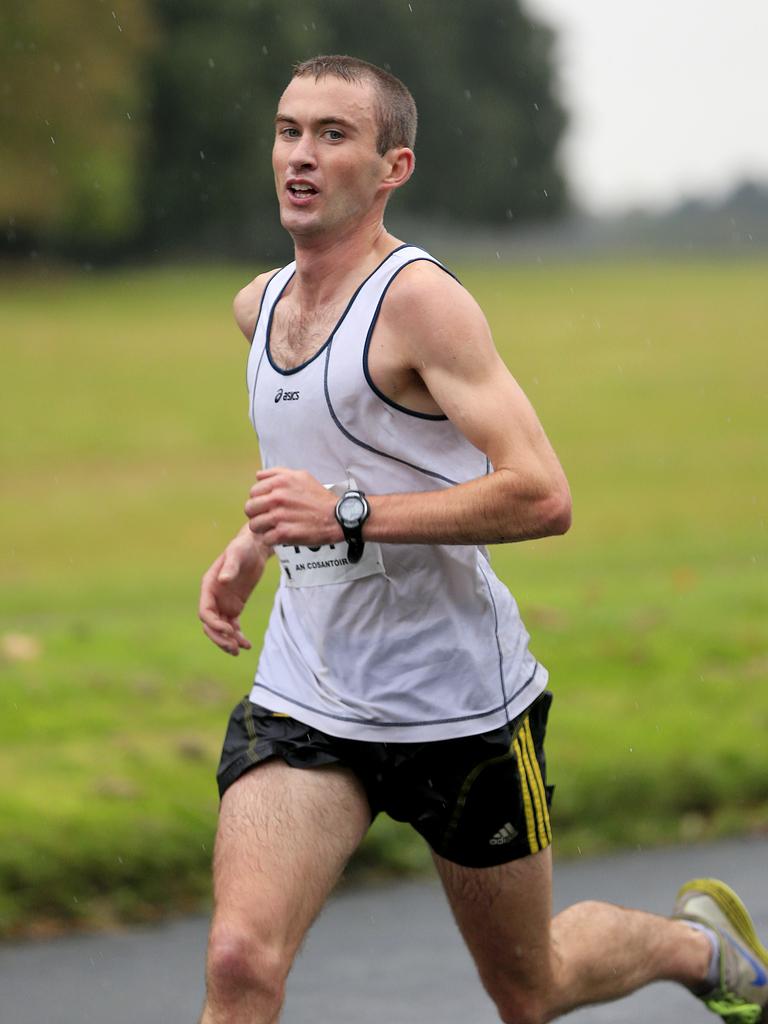What athletic brand is his shirt from?
Your answer should be compact. Asics. Are his shorts adidas?
Provide a short and direct response. Yes. 